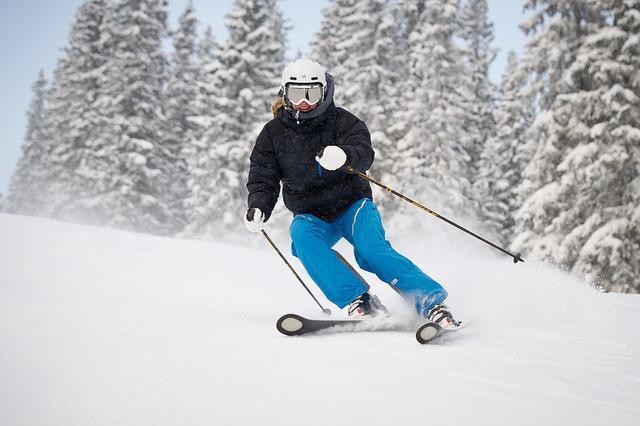How many people are wearing orange shirts in the picture?
Give a very brief answer. 0. 